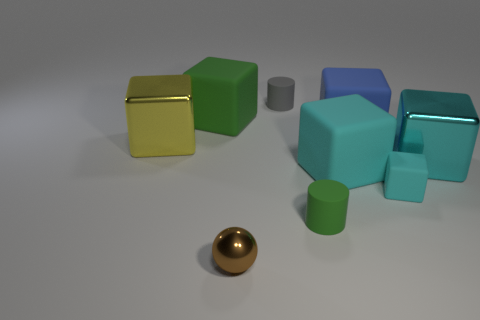Subtract all purple cylinders. How many cyan cubes are left? 3 Subtract all yellow blocks. How many blocks are left? 5 Subtract all yellow blocks. How many blocks are left? 5 Add 1 tiny cyan matte cubes. How many objects exist? 10 Subtract all brown cubes. Subtract all green cylinders. How many cubes are left? 6 Add 7 small cylinders. How many small cylinders exist? 9 Subtract 0 yellow balls. How many objects are left? 9 Subtract all balls. How many objects are left? 8 Subtract all big green blocks. Subtract all green rubber cylinders. How many objects are left? 7 Add 2 cyan cubes. How many cyan cubes are left? 5 